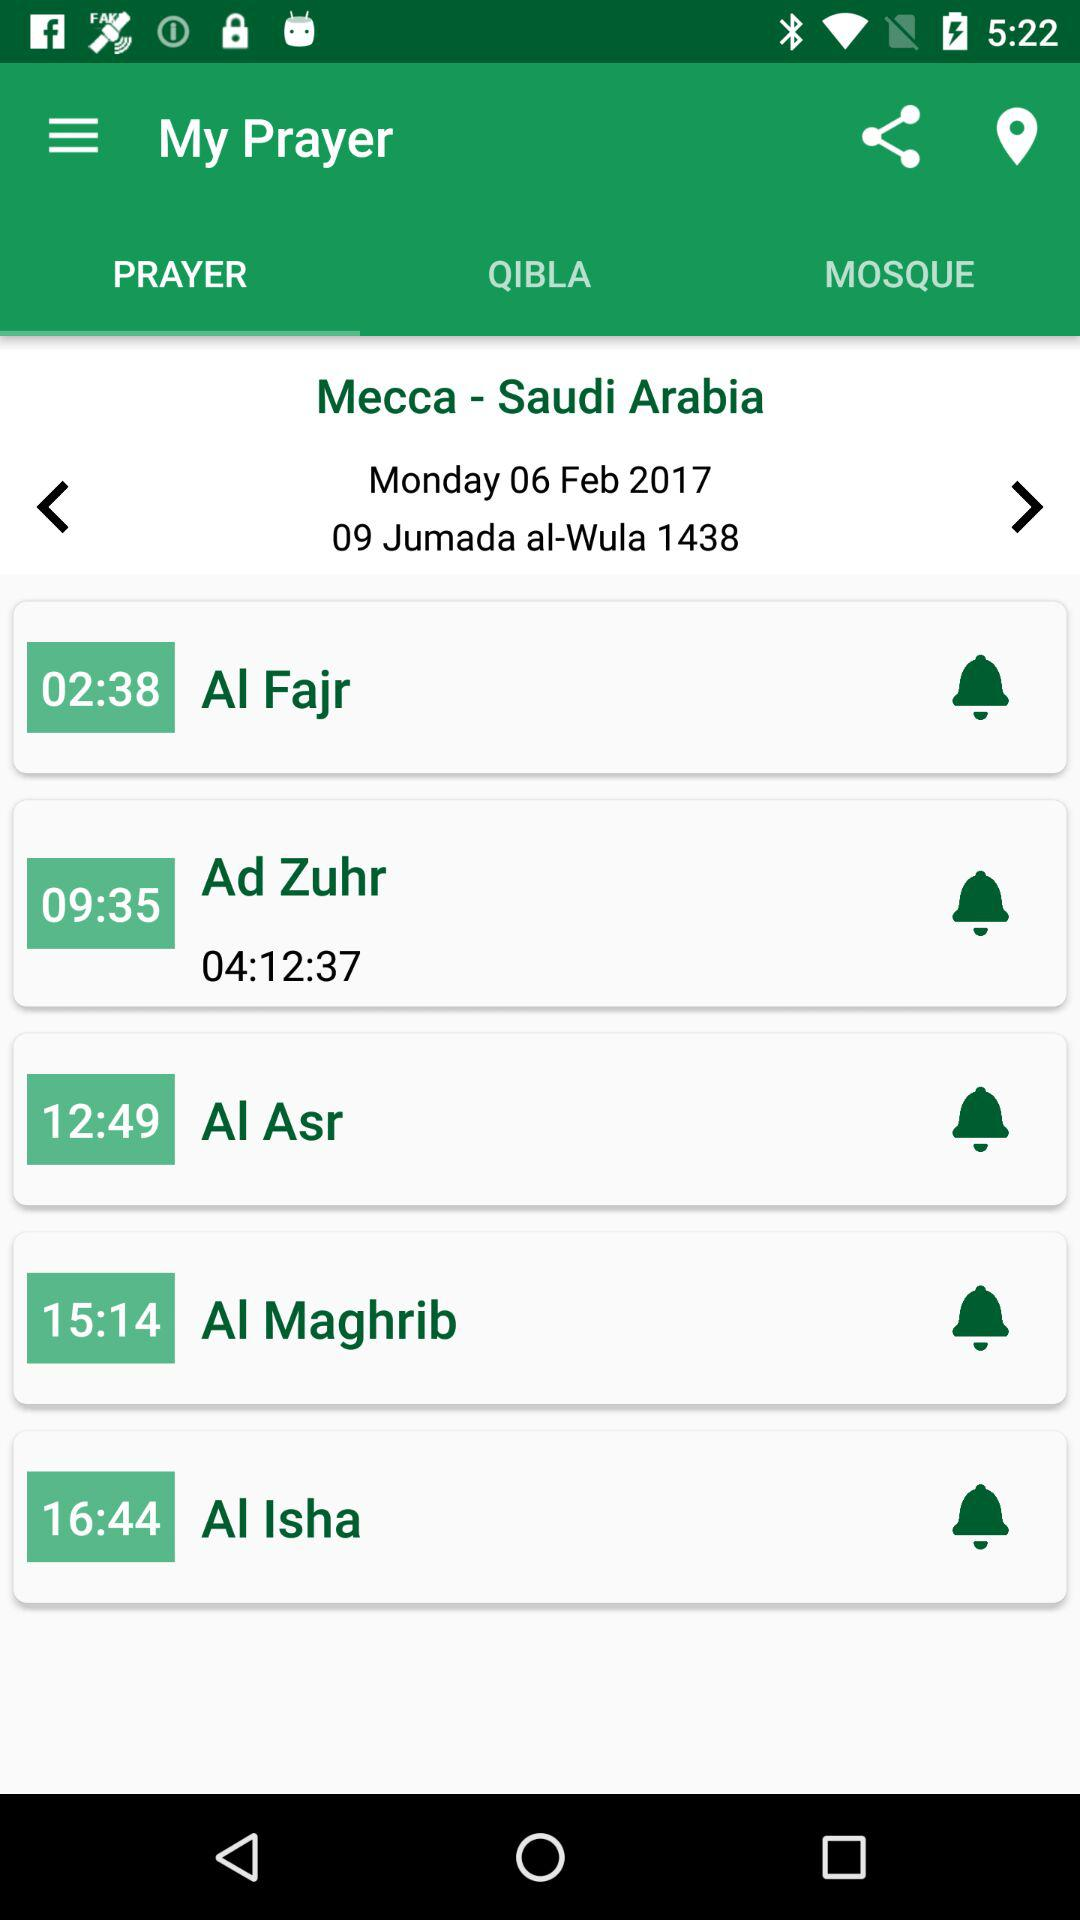What is the time duration of the "Ad Zuhr"? The time duration of the "Ad Zuhr" is 4 hours 12 minutes 37 seconds. 